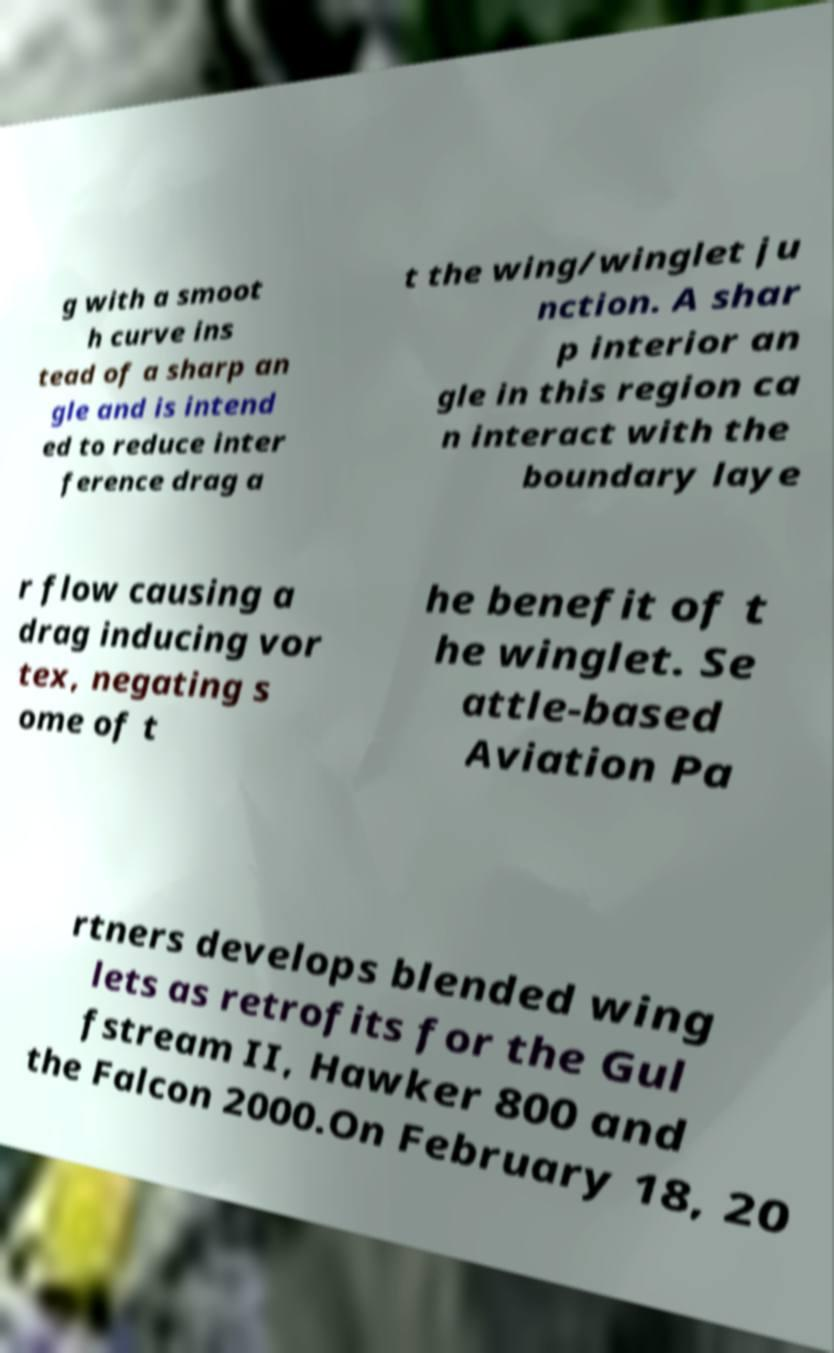Please identify and transcribe the text found in this image. g with a smoot h curve ins tead of a sharp an gle and is intend ed to reduce inter ference drag a t the wing/winglet ju nction. A shar p interior an gle in this region ca n interact with the boundary laye r flow causing a drag inducing vor tex, negating s ome of t he benefit of t he winglet. Se attle-based Aviation Pa rtners develops blended wing lets as retrofits for the Gul fstream II, Hawker 800 and the Falcon 2000.On February 18, 20 